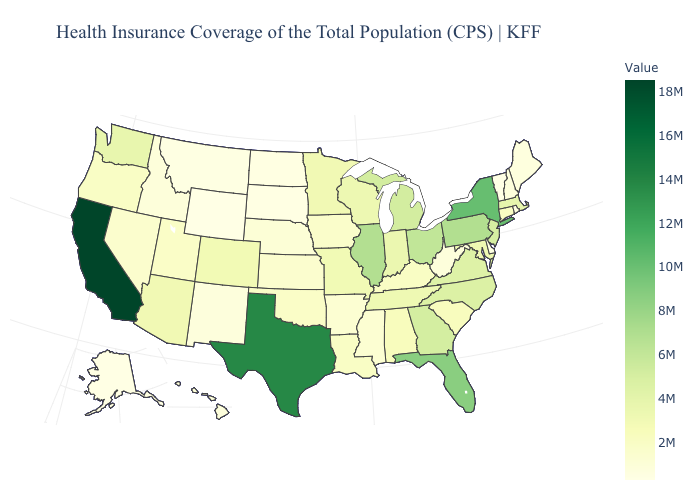Does South Carolina have a lower value than Virginia?
Be succinct. Yes. 